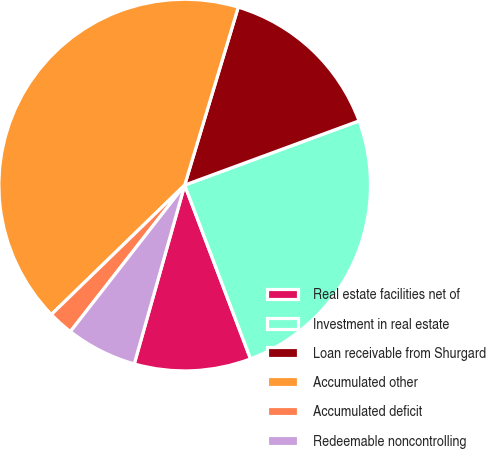Convert chart. <chart><loc_0><loc_0><loc_500><loc_500><pie_chart><fcel>Real estate facilities net of<fcel>Investment in real estate<fcel>Loan receivable from Shurgard<fcel>Accumulated other<fcel>Accumulated deficit<fcel>Redeemable noncontrolling<nl><fcel>10.14%<fcel>24.85%<fcel>14.73%<fcel>41.92%<fcel>2.19%<fcel>6.17%<nl></chart> 